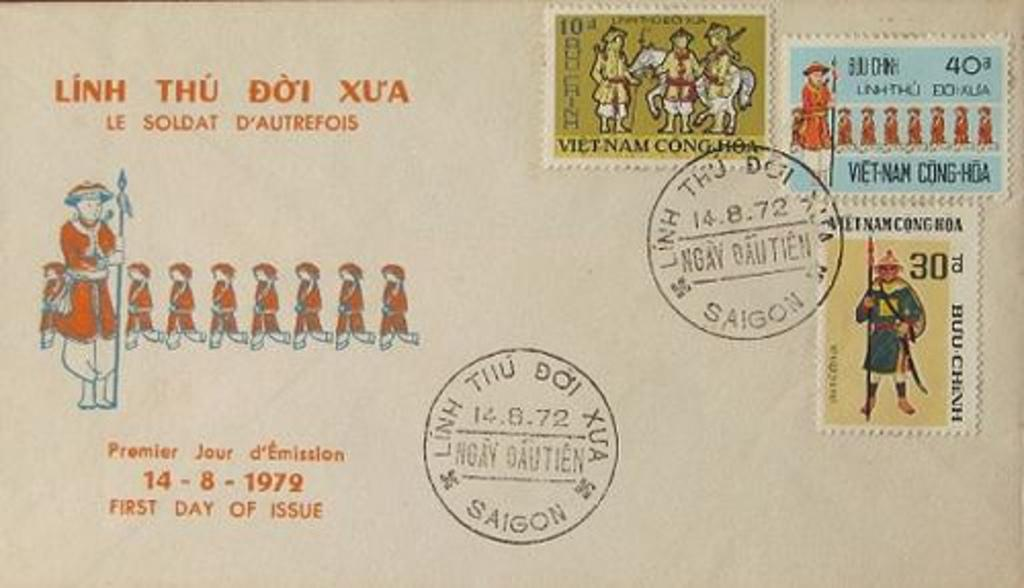<image>
Share a concise interpretation of the image provided. A post card from Saigon with three stamps. 